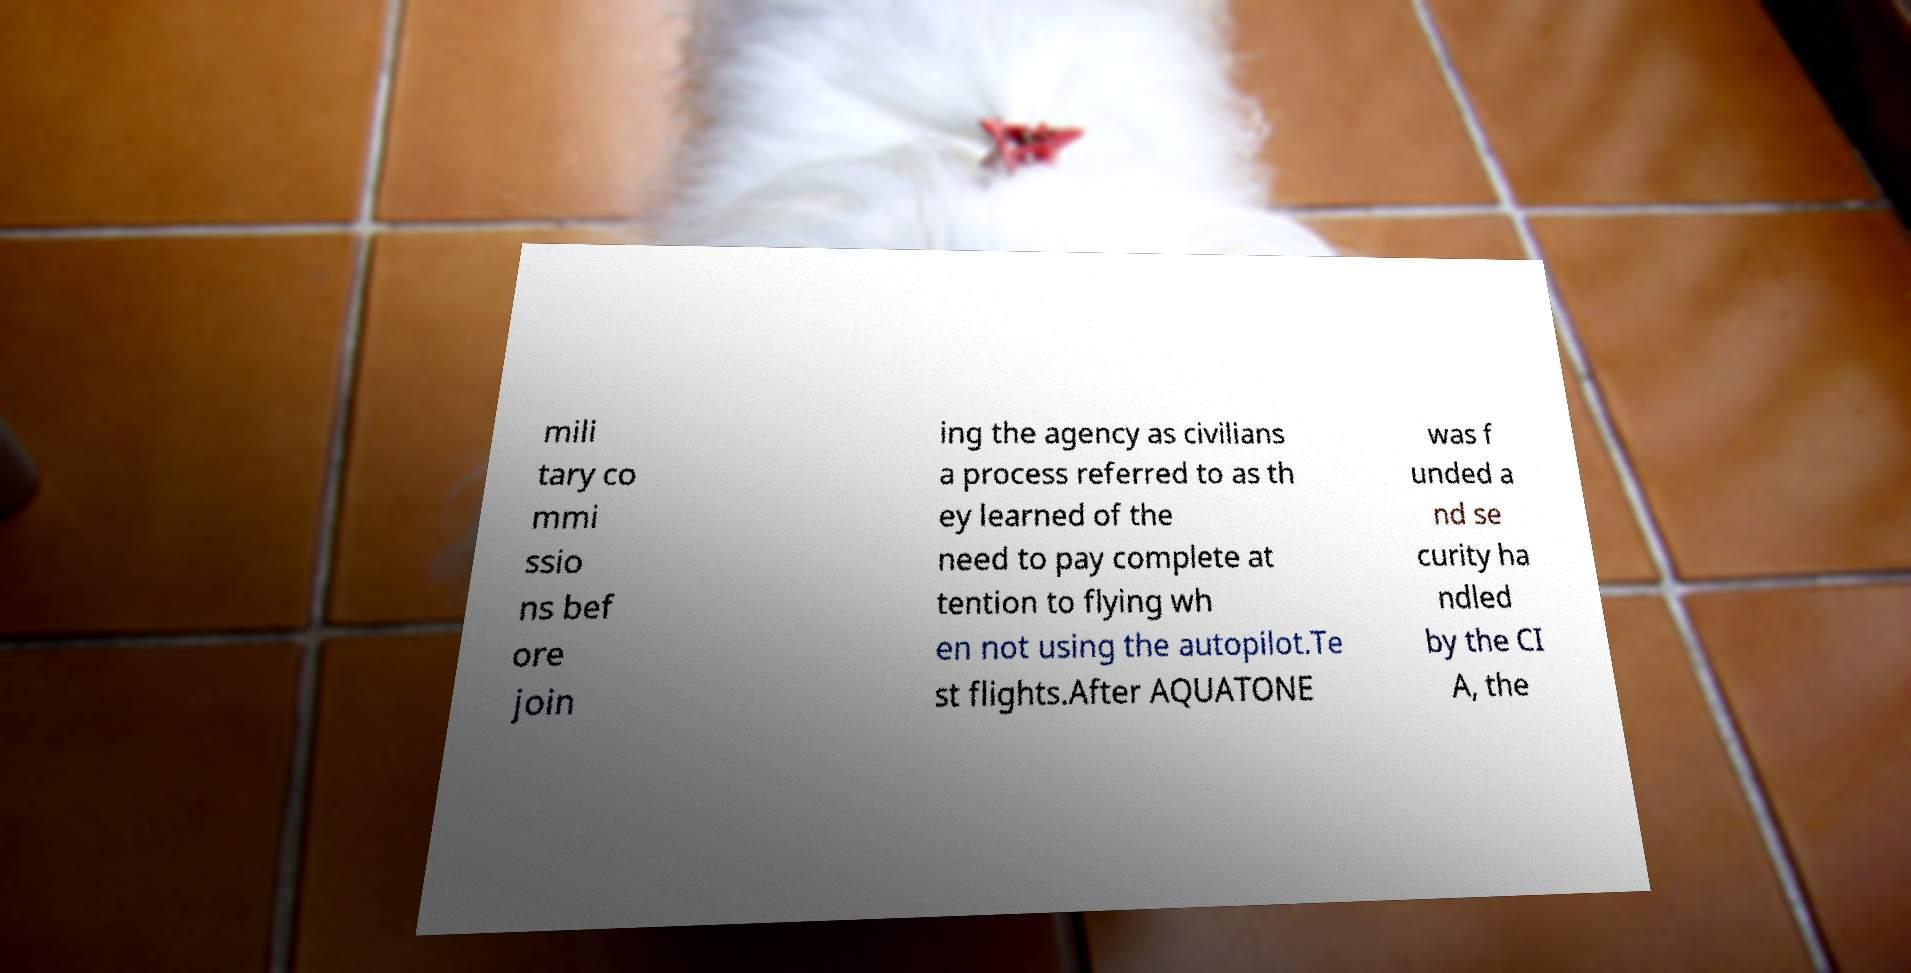Can you read and provide the text displayed in the image?This photo seems to have some interesting text. Can you extract and type it out for me? mili tary co mmi ssio ns bef ore join ing the agency as civilians a process referred to as th ey learned of the need to pay complete at tention to flying wh en not using the autopilot.Te st flights.After AQUATONE was f unded a nd se curity ha ndled by the CI A, the 